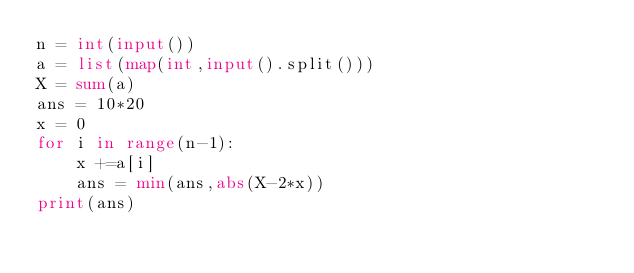Convert code to text. <code><loc_0><loc_0><loc_500><loc_500><_Python_>n = int(input())
a = list(map(int,input().split()))
X = sum(a)
ans = 10*20
x = 0
for i in range(n-1):
    x +=a[i]
    ans = min(ans,abs(X-2*x))
print(ans)
    
</code> 